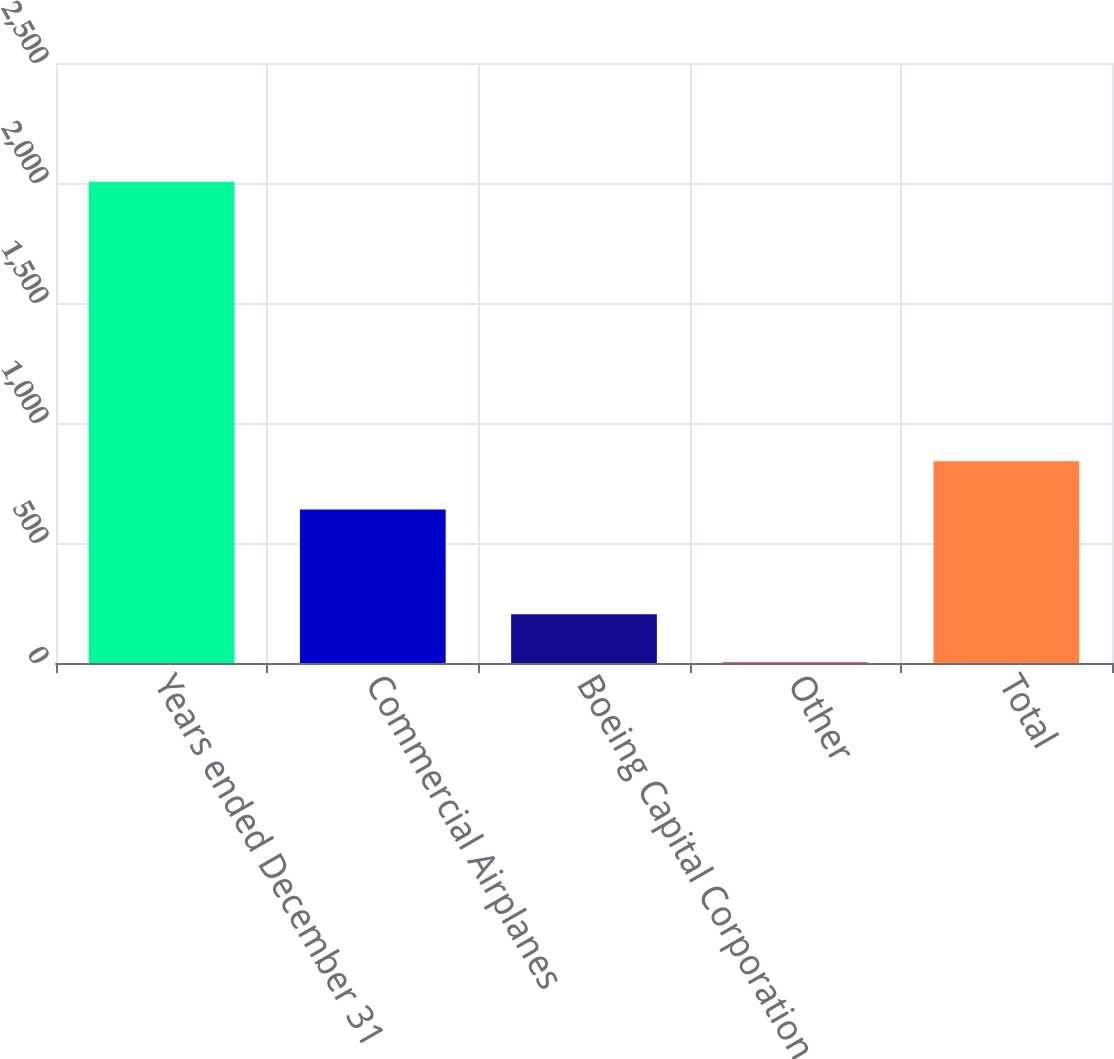Convert chart to OTSL. <chart><loc_0><loc_0><loc_500><loc_500><bar_chart><fcel>Years ended December 31<fcel>Commercial Airplanes<fcel>Boeing Capital Corporation<fcel>Other<fcel>Total<nl><fcel>2005<fcel>640<fcel>203.2<fcel>3<fcel>840.2<nl></chart> 